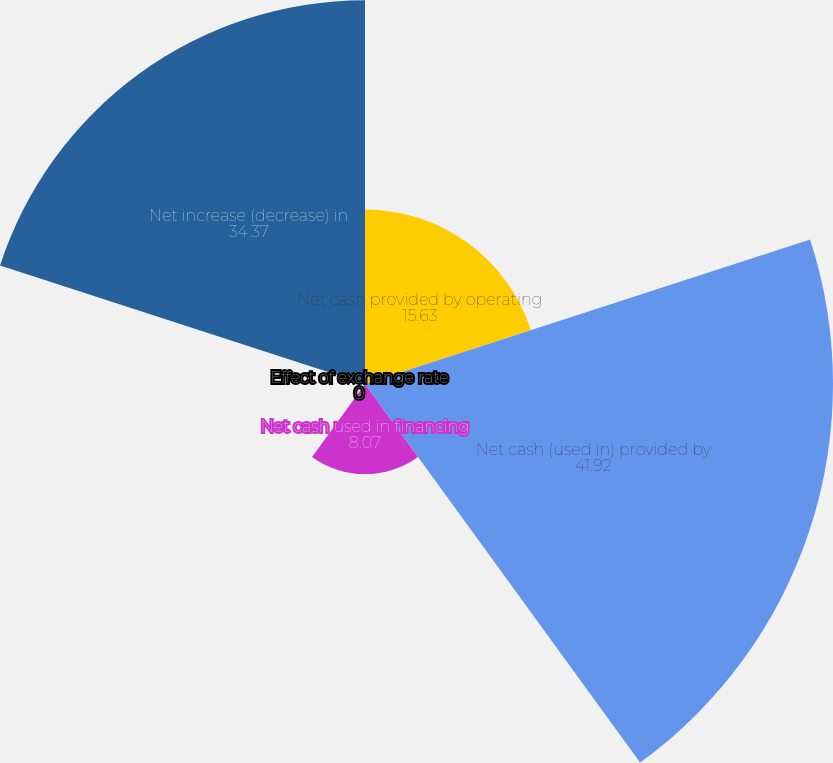Convert chart. <chart><loc_0><loc_0><loc_500><loc_500><pie_chart><fcel>Net cash provided by operating<fcel>Net cash (used in) provided by<fcel>Net cash used in financing<fcel>Effect of exchange rate<fcel>Net increase (decrease) in<nl><fcel>15.63%<fcel>41.92%<fcel>8.07%<fcel>0.0%<fcel>34.37%<nl></chart> 